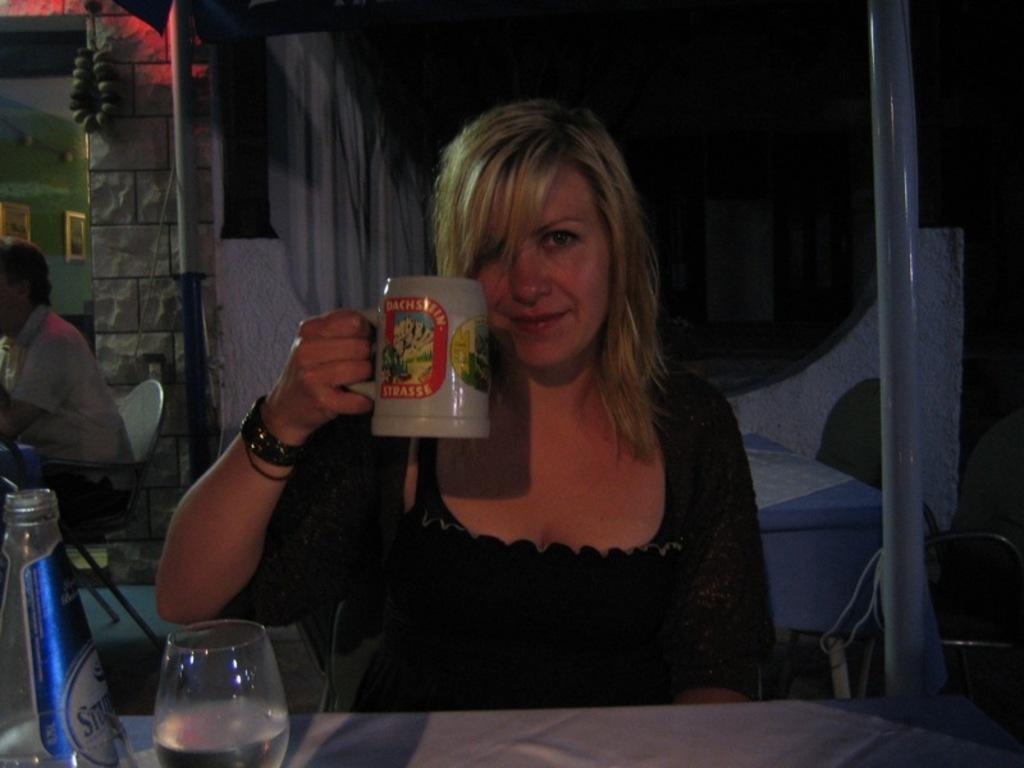Can you describe this image briefly? In this image we can see two persons. In front the woman is holding a cup. At the background we can see a wall and frames are attached to the wall. 